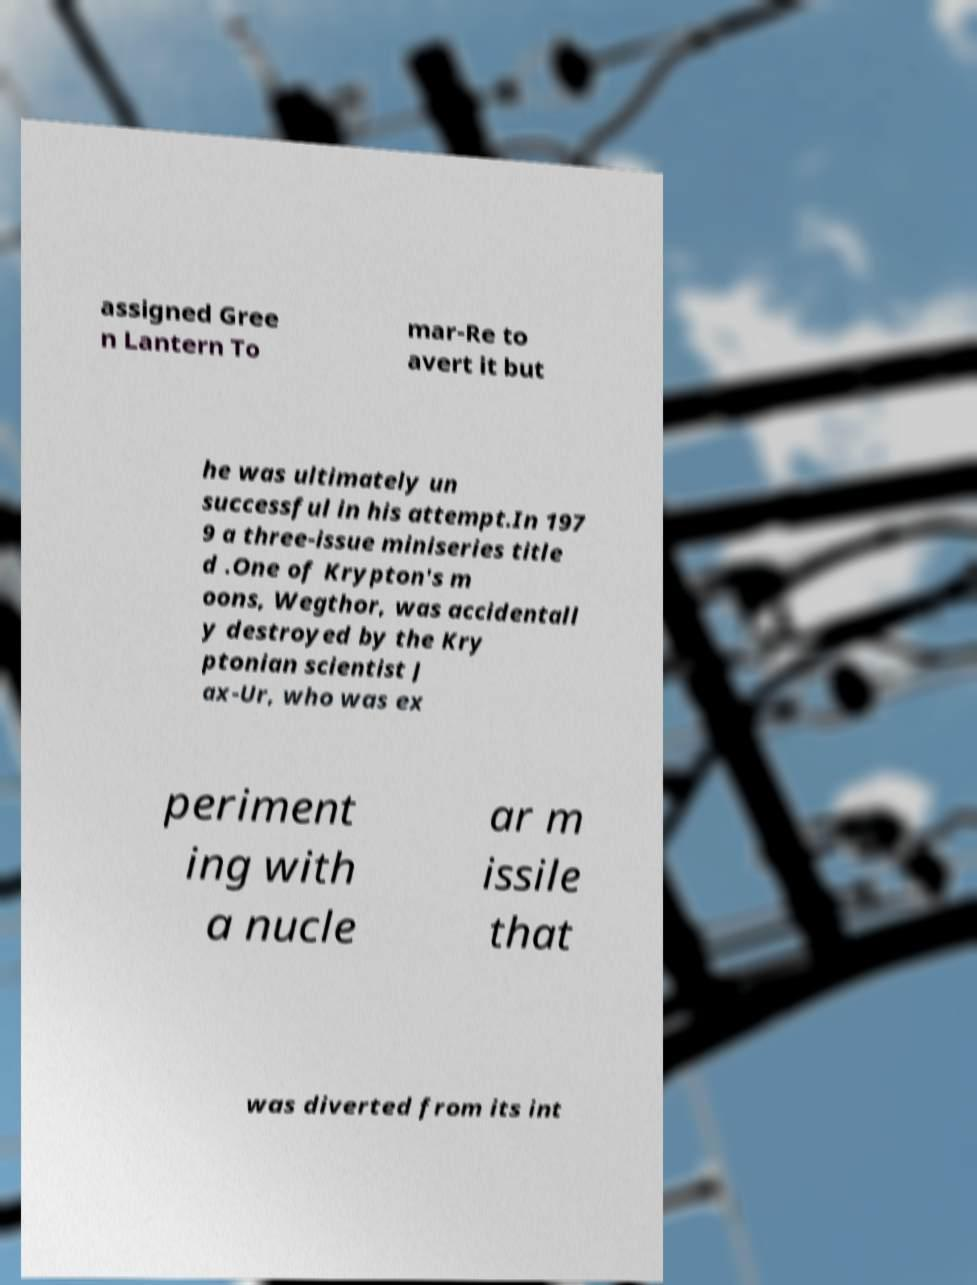Can you read and provide the text displayed in the image?This photo seems to have some interesting text. Can you extract and type it out for me? assigned Gree n Lantern To mar-Re to avert it but he was ultimately un successful in his attempt.In 197 9 a three-issue miniseries title d .One of Krypton's m oons, Wegthor, was accidentall y destroyed by the Kry ptonian scientist J ax-Ur, who was ex periment ing with a nucle ar m issile that was diverted from its int 